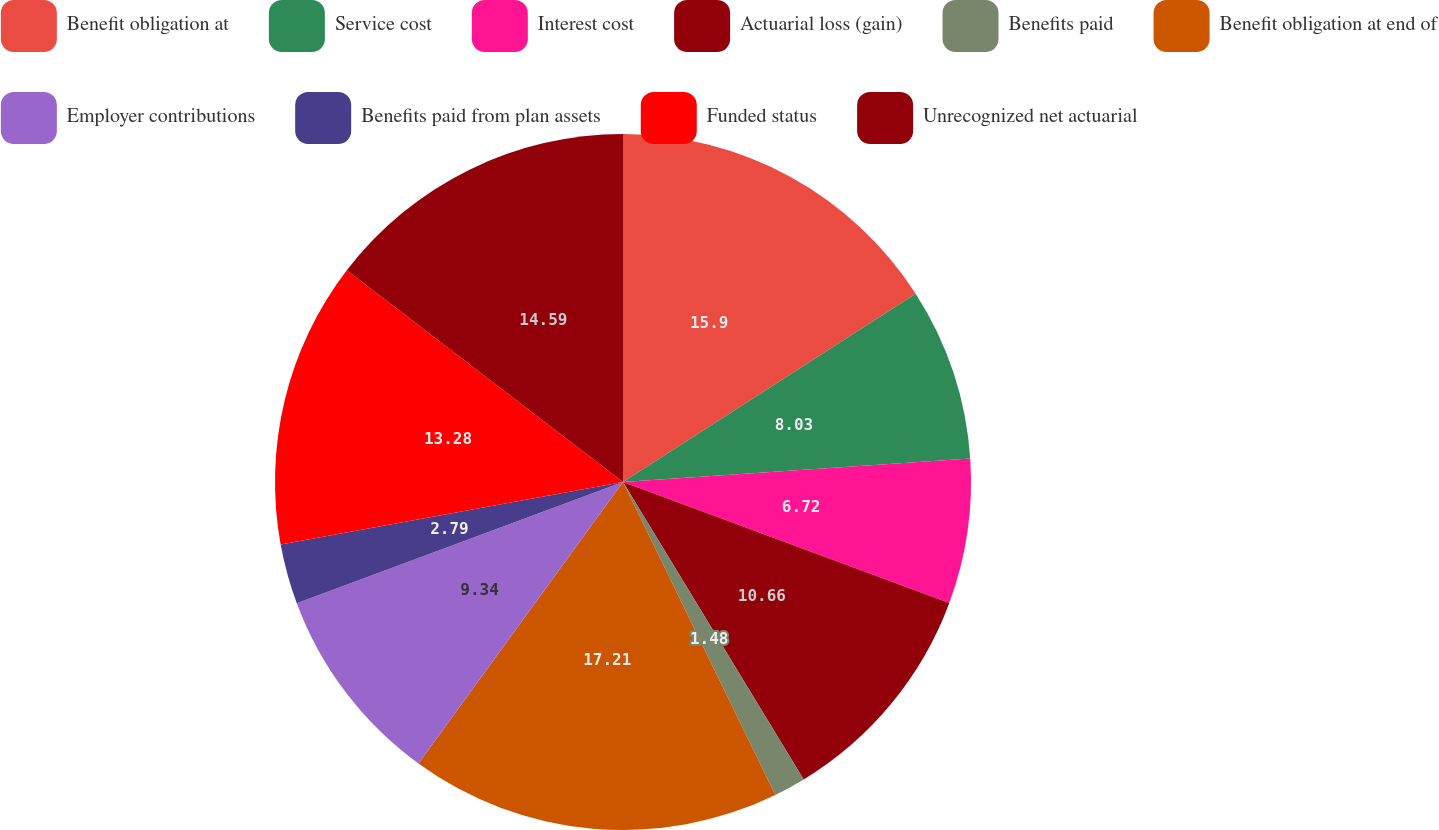Convert chart. <chart><loc_0><loc_0><loc_500><loc_500><pie_chart><fcel>Benefit obligation at<fcel>Service cost<fcel>Interest cost<fcel>Actuarial loss (gain)<fcel>Benefits paid<fcel>Benefit obligation at end of<fcel>Employer contributions<fcel>Benefits paid from plan assets<fcel>Funded status<fcel>Unrecognized net actuarial<nl><fcel>15.9%<fcel>8.03%<fcel>6.72%<fcel>10.66%<fcel>1.48%<fcel>17.21%<fcel>9.34%<fcel>2.79%<fcel>13.28%<fcel>14.59%<nl></chart> 